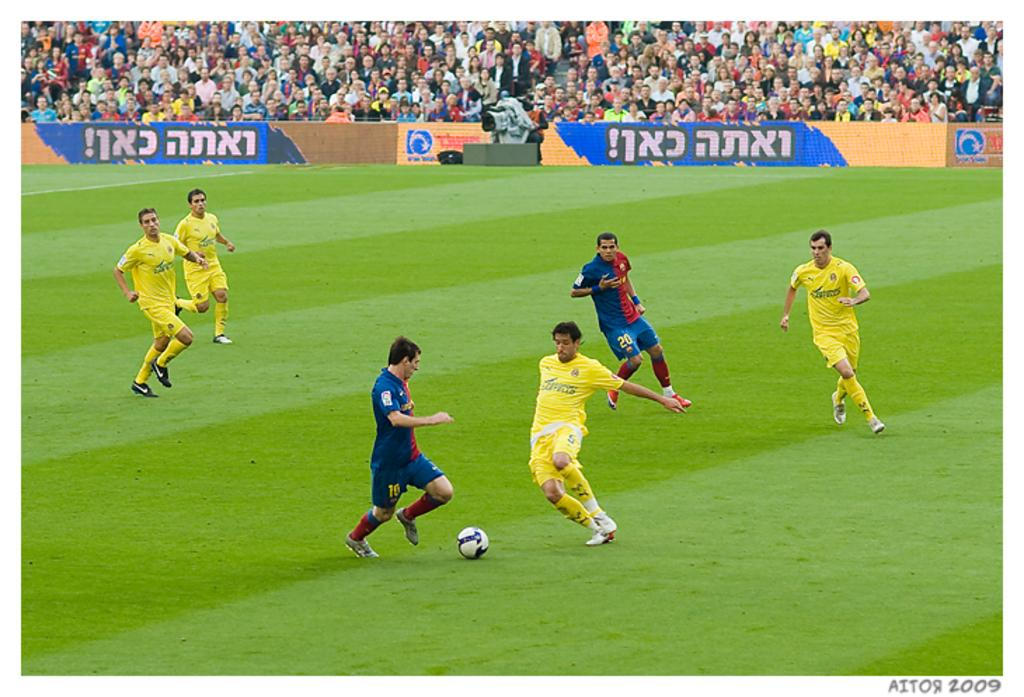<image>
Create a compact narrative representing the image presented. Two players from opposing teams approach the ball, the man about to kick the ball has a 15 on his shorts 